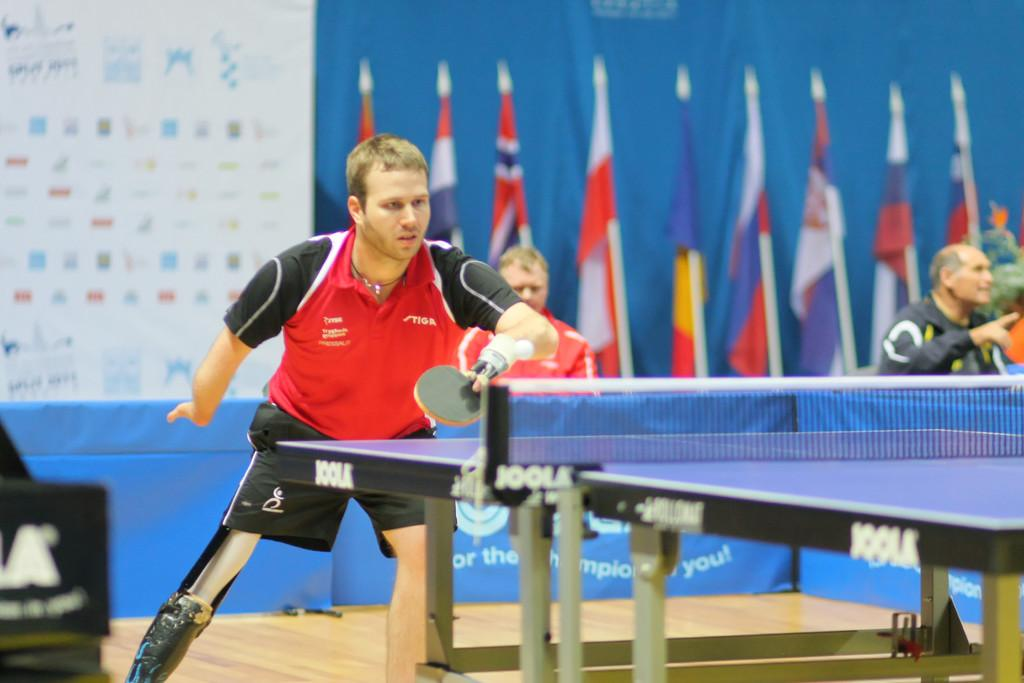Provide a one-sentence caption for the provided image. a man plays on a Joolk ping pong table. 